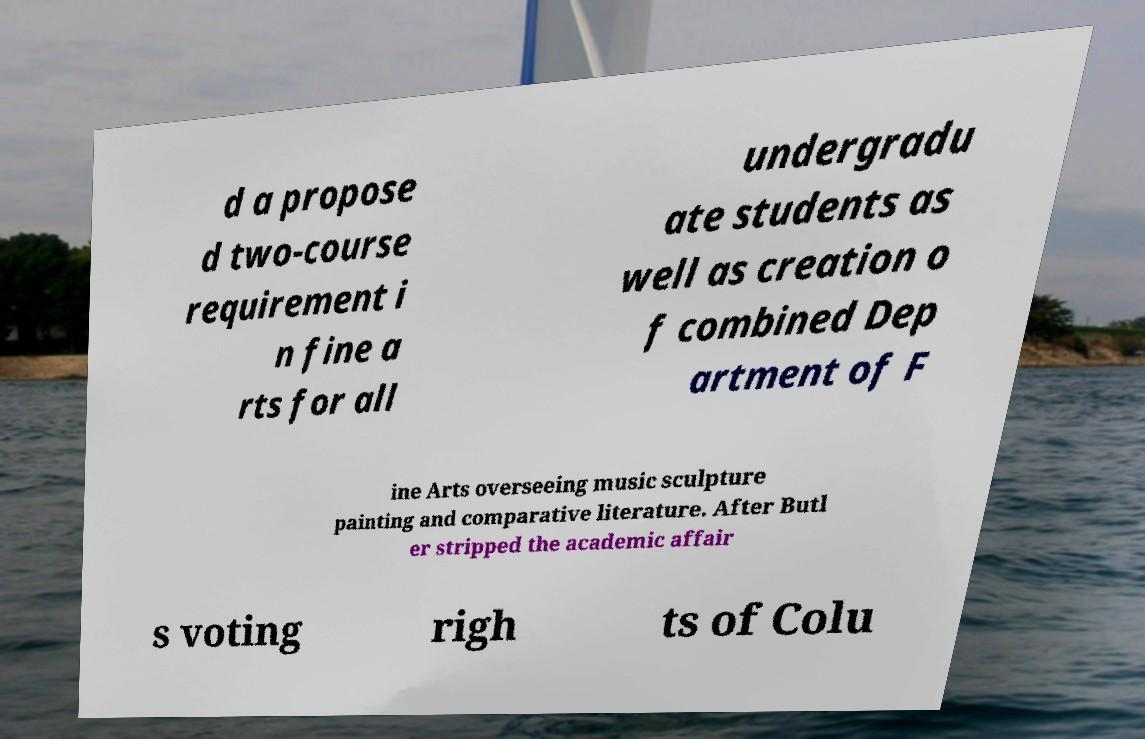Can you read and provide the text displayed in the image?This photo seems to have some interesting text. Can you extract and type it out for me? d a propose d two-course requirement i n fine a rts for all undergradu ate students as well as creation o f combined Dep artment of F ine Arts overseeing music sculpture painting and comparative literature. After Butl er stripped the academic affair s voting righ ts of Colu 